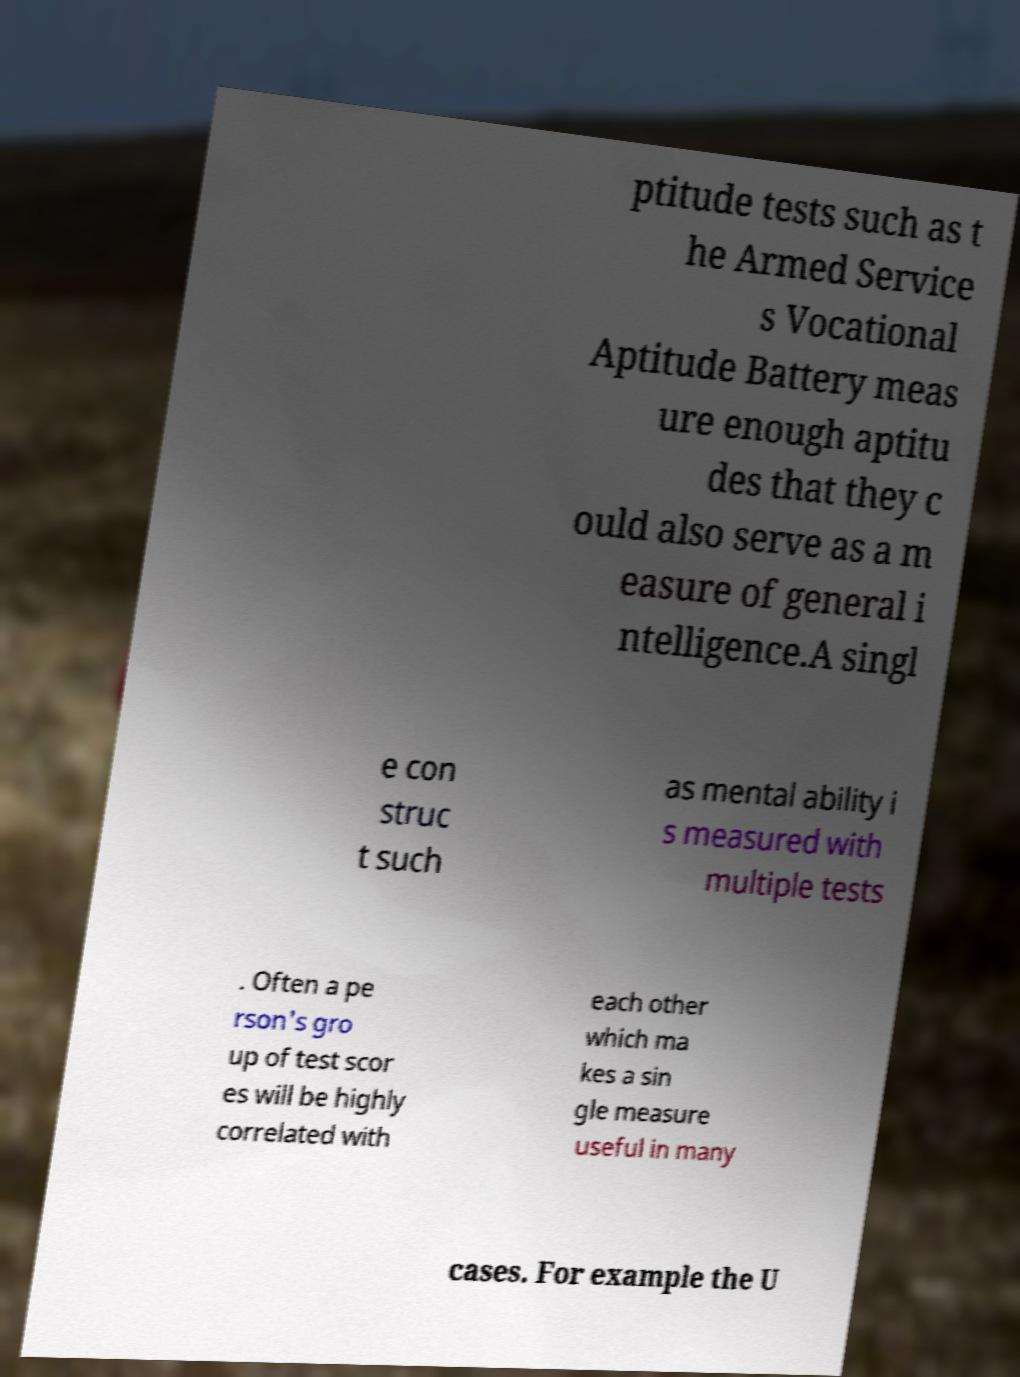Can you accurately transcribe the text from the provided image for me? ptitude tests such as t he Armed Service s Vocational Aptitude Battery meas ure enough aptitu des that they c ould also serve as a m easure of general i ntelligence.A singl e con struc t such as mental ability i s measured with multiple tests . Often a pe rson's gro up of test scor es will be highly correlated with each other which ma kes a sin gle measure useful in many cases. For example the U 